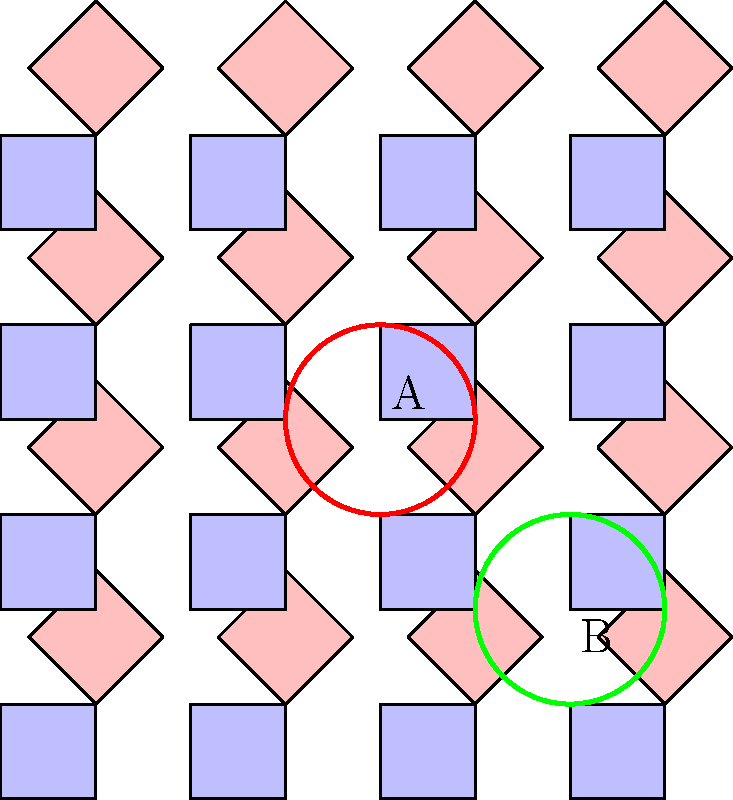In the geometric pattern inspired by traditional Sri Lankan art, point A is located at (4,4). If this pattern undergoes a translation of (-2, 2), what will be the new coordinates of point B? To solve this problem, we need to follow these steps:

1. Identify the current coordinates of point B:
   Point B is located at (6, 2)

2. Understand the translation vector:
   The translation is (-2, 2), which means we move 2 units left and 2 units up.

3. Apply the translation to point B:
   - x-coordinate: 6 + (-2) = 4
   - y-coordinate: 2 + 2 = 4

4. Calculate the new coordinates of point B:
   After translation, point B will be at (4, 4)

5. Verify the result:
   The new position of B coincides with the original position of A, which makes sense given the symmetry of the pattern and the nature of the translation.
Answer: (4, 4) 